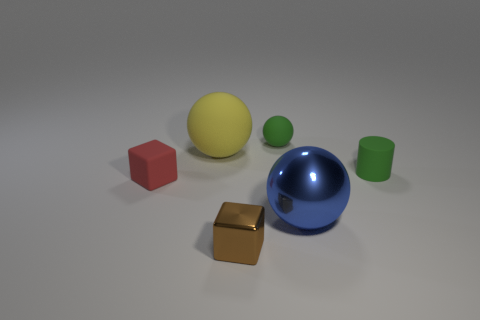Add 3 green matte cylinders. How many objects exist? 9 Subtract all blocks. How many objects are left? 4 Add 4 brown shiny cubes. How many brown shiny cubes are left? 5 Add 4 yellow matte spheres. How many yellow matte spheres exist? 5 Subtract 0 cyan balls. How many objects are left? 6 Subtract all small blocks. Subtract all big balls. How many objects are left? 2 